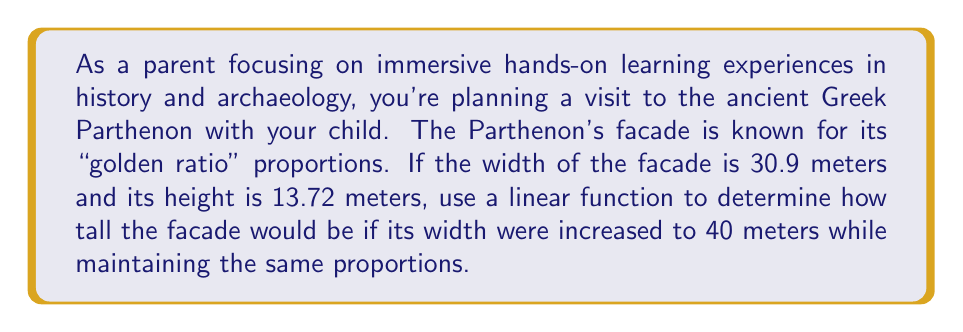Teach me how to tackle this problem. To solve this problem, we'll use a linear function to model the relationship between the width and height of the Parthenon's facade. Let's follow these steps:

1. Define our variables:
   Let $x$ represent the width and $y$ represent the height.

2. Find the slope of the line (the rate of change):
   Slope $m = \frac{\text{change in y}}{\text{change in x}} = \frac{\text{height}}{\text{width}} = \frac{13.72}{30.9} \approx 0.4440$

3. Write the linear function in slope-intercept form:
   $y = mx + b$, where $m$ is the slope and $b$ is the y-intercept.

4. Since we know the facade's proportions pass through the origin (0,0), our y-intercept is 0.
   Therefore, our linear function is:
   $y = 0.4440x$

5. To find the height when the width is 40 meters, substitute $x = 40$ into our equation:
   $y = 0.4440(40) = 17.76$

Therefore, if the facade's width were increased to 40 meters while maintaining the same proportions, its height would be 17.76 meters.

This problem demonstrates how linear functions can be used to analyze and scale architectural proportions, providing a practical application of mathematics in historical and archaeological contexts.
Answer: 17.76 meters 